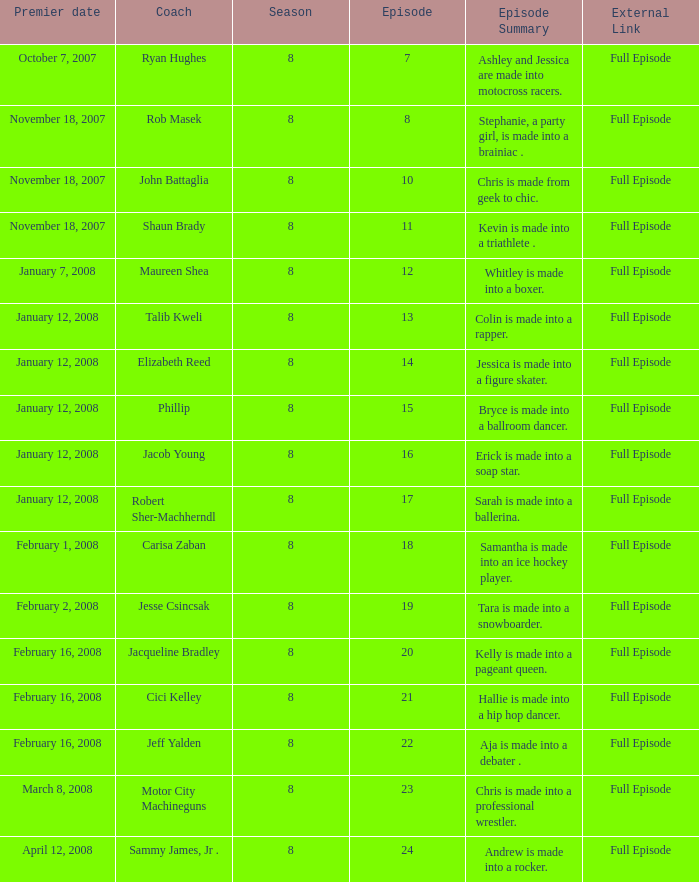What coach premiered February 16, 2008 later than episode 21.0? Jeff Yalden. 